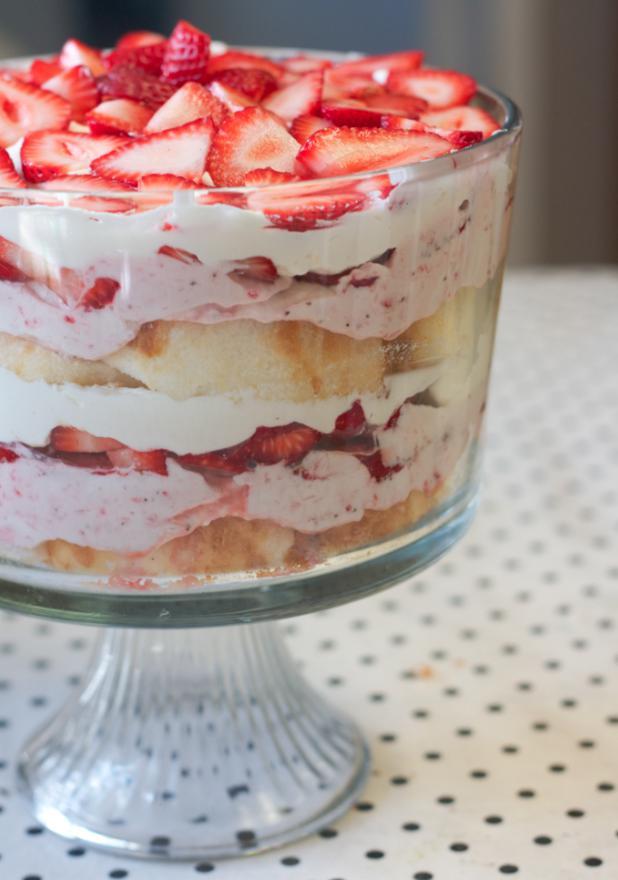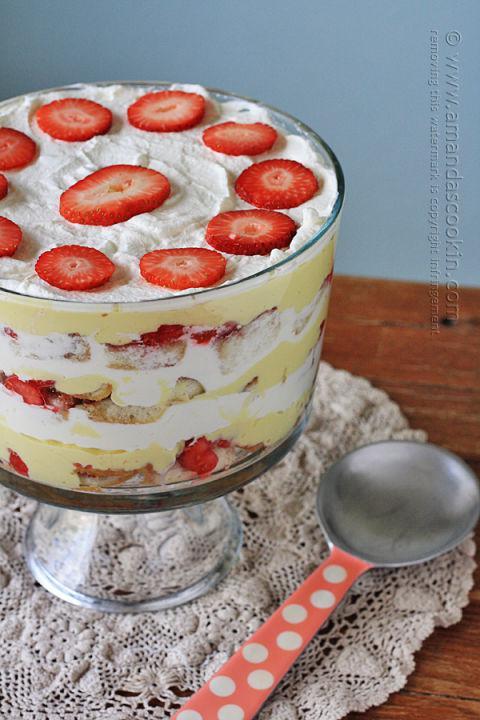The first image is the image on the left, the second image is the image on the right. Given the left and right images, does the statement "The serving dish in the image on the right has a pedastal." hold true? Answer yes or no. Yes. The first image is the image on the left, the second image is the image on the right. For the images shown, is this caption "At least one image shows a dessert garnished only with strawberry slices." true? Answer yes or no. Yes. 